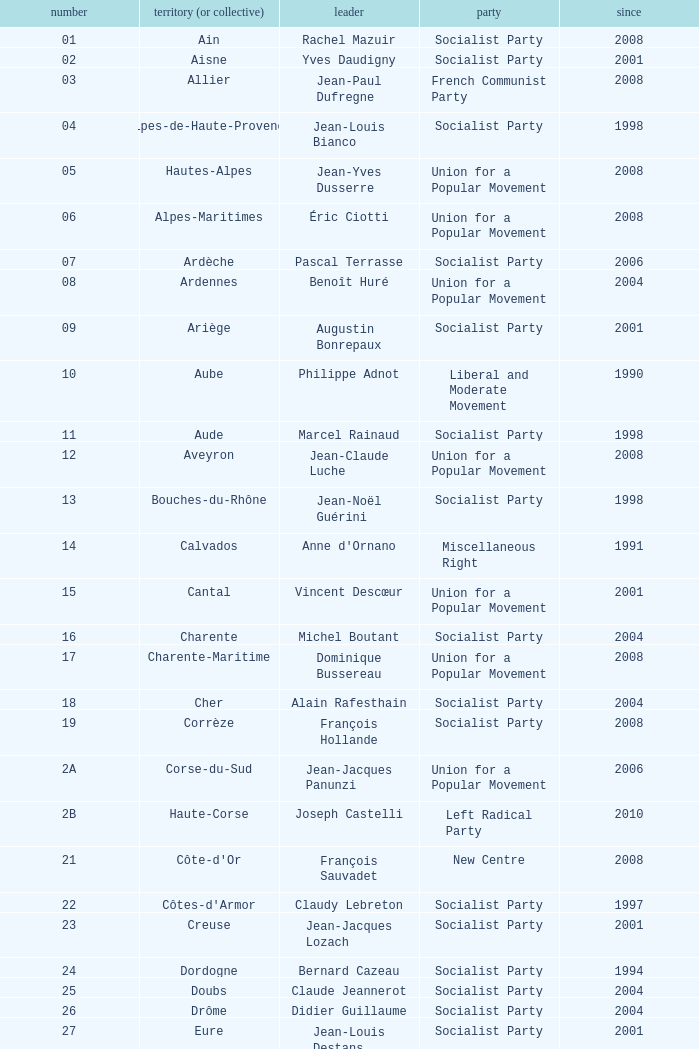What number corresponds to Presidet Yves Krattinger of the Socialist party? 70.0. 